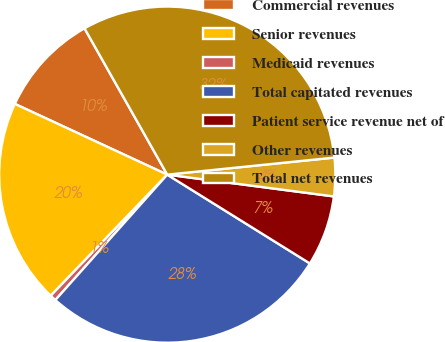Convert chart. <chart><loc_0><loc_0><loc_500><loc_500><pie_chart><fcel>Commercial revenues<fcel>Senior revenues<fcel>Medicaid revenues<fcel>Total capitated revenues<fcel>Patient service revenue net of<fcel>Other revenues<fcel>Total net revenues<nl><fcel>9.89%<fcel>19.72%<fcel>0.6%<fcel>27.73%<fcel>6.79%<fcel>3.69%<fcel>31.57%<nl></chart> 